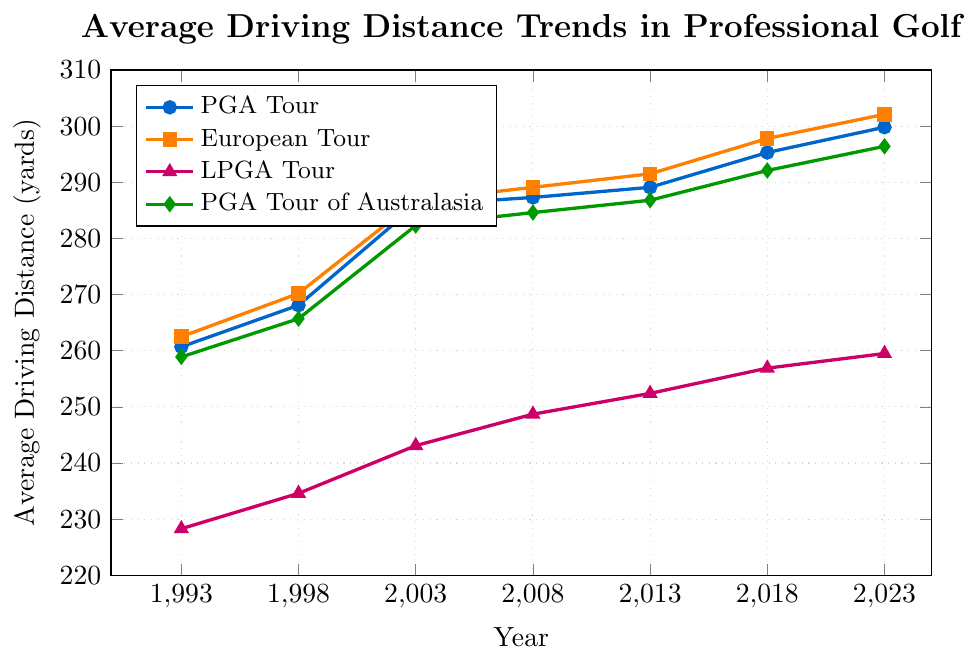What is the trend in the average driving distance for the PGA Tour from 1993 to 2023? Look at the line representing the PGA Tour and observe its slope. The line shows an overall upward trend over the years. In 1993, the average driving distance was 260.7 yards, and it increased steadily to 299.8 yards by 2023.
Answer: Upward trend Which tour had the highest average driving distance in 2023? Compare the heights of the lines at the rightmost end (2023). The European Tour reaches the highest point at 302.1 yards.
Answer: European Tour By how many yards did the average driving distance for the LPGA Tour increase from 1993 to 2023? Subtract the 1993 value from the 2023 value for the LPGA Tour. The average distance increased from 228.3 yards in 1993 to 259.5 yards in 2023. Thus, 259.5 - 228.3 = 31.2 yards.
Answer: 31.2 yards Which tour had the smallest growth in average driving distance from 1993 to 2023? Calculate the differences for each tour from 1993 to 2023 and compare. PGA Tour: 299.8 - 260.7 = 39.1 yards, European Tour: 302.1 - 262.5 = 39.6 yards, LPGA Tour: 259.5 - 228.3 = 31.2 yards, PGA Tour of Australasia: 296.4 - 258.9 = 37.5 yards. The LPGA Tour had the smallest growth at 31.2 yards.
Answer: LPGA Tour In which year did the European Tour surpass an average driving distance of 290 yards? Identify where the line for the European Tour crosses the 290-yard mark. The line crosses above 290 yards in 2008.
Answer: 2008 Compare the average driving distances of the PGA Tour and PGA Tour of Australasia in 2018. Which was higher and by how much? Look at the values for 2018 for both tours. PGA Tour: 295.3 yards, PGA Tour of Australasia: 292.1 yards. The PGA Tour was higher by 295.3 - 292.1 = 3.2 yards.
Answer: PGA Tour by 3.2 yards What is the difference in the growth rates between the PGA Tour and the European Tour from 1993 to 2023? Calculate the growth rate for both tours from 1993 to 2023. PGA Tour: 299.8 - 260.7 = 39.1 yards, European Tour: 302.1 - 262.5 = 39.6 yards. The difference is 39.6 - 39.1 = 0.5 yards.
Answer: 0.5 yards Which tour showed the most consistent growth trend over the period from 1993 to 2023? Observe the smoothness and steadiness of the lines over time. The LPGA Tour shows a consistent upward slope without significant fluctuations.
Answer: LPGA Tour 